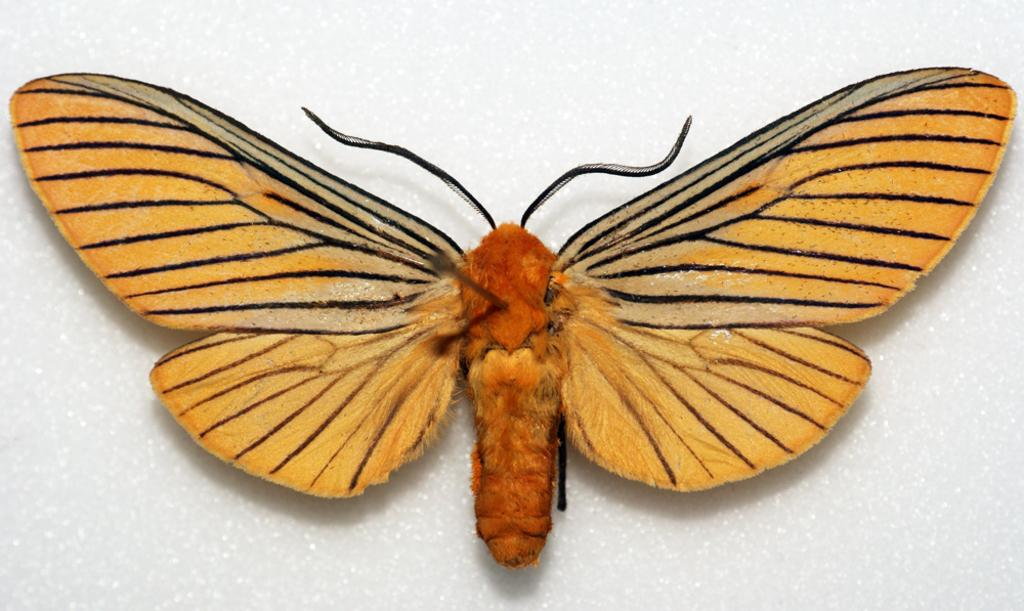What is the main subject of the image? There is a butterfly in the image. Where is the butterfly located? The butterfly is on the wall. What type of credit can be seen on the butterfly's wings in the image? There is no credit or any financial information present on the butterfly's wings in the image. 